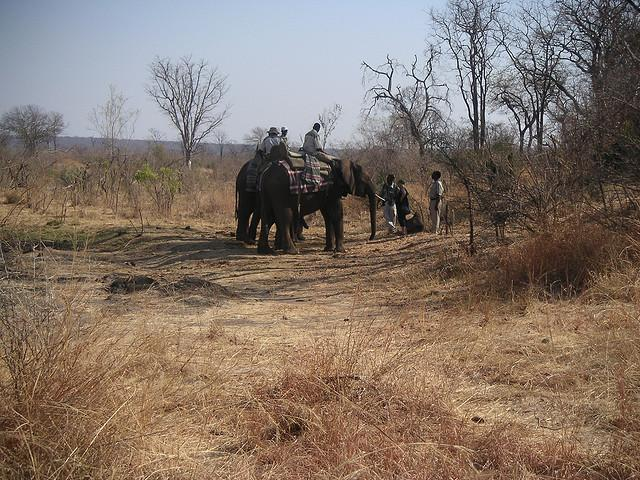Why is there a saddle on the elephant? Please explain your reasoning. to ride. People are sitting on top of an elephant. 